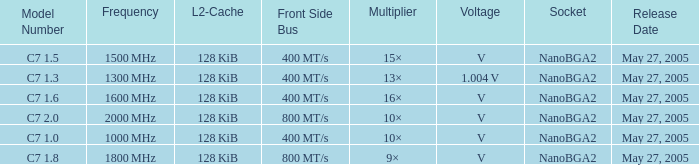What is the Frequency for Model Number c7 1.0? 1000 MHz. 